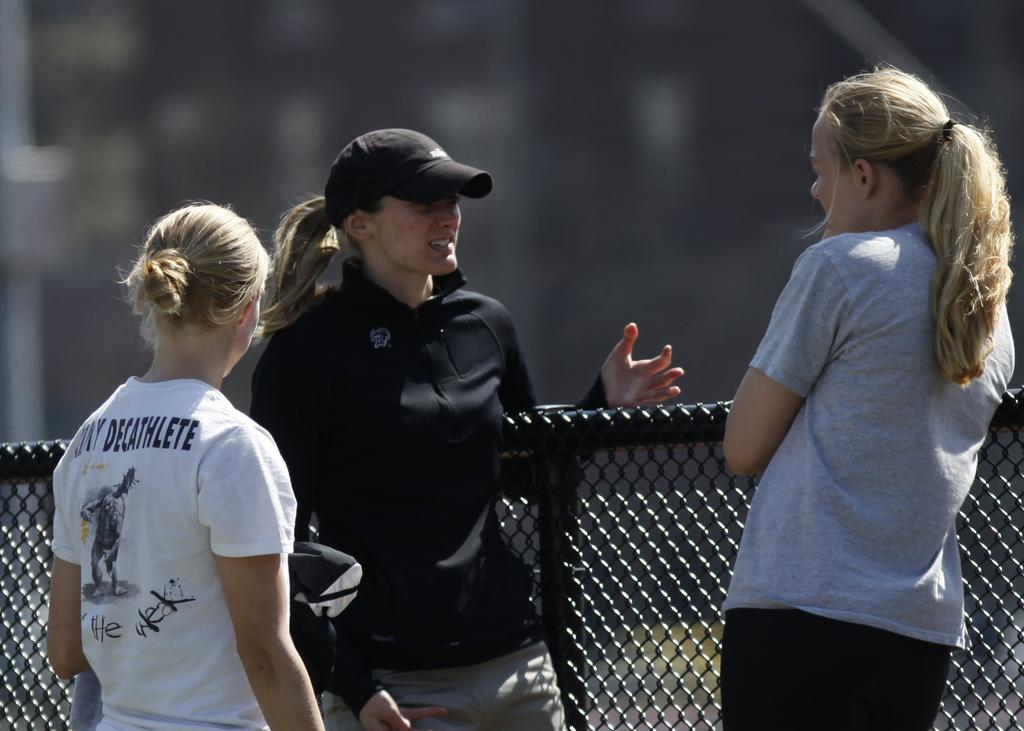How many people are in the image? There are three persons standing in the image. What can be seen in the background of the image? The background of the image is blurred. Is there any specific feature in the image besides the people? Yes, there is a wire fence in the image. Can you see any apples in the cellar in the image? There is no cellar or apples present in the image. 